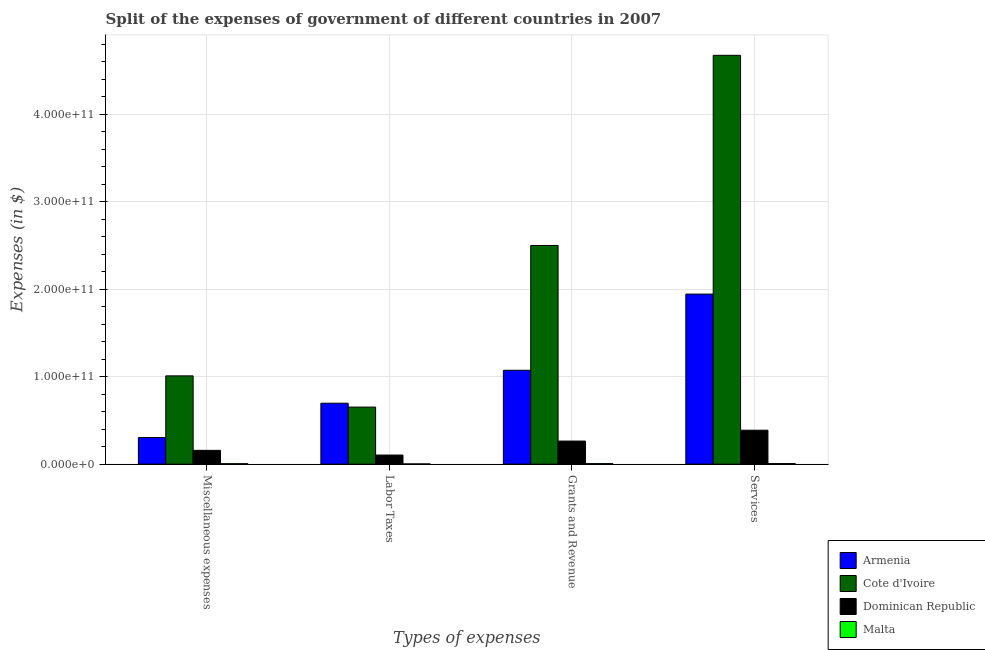How many different coloured bars are there?
Provide a succinct answer. 4. Are the number of bars per tick equal to the number of legend labels?
Offer a very short reply. Yes. How many bars are there on the 2nd tick from the left?
Offer a very short reply. 4. How many bars are there on the 2nd tick from the right?
Your response must be concise. 4. What is the label of the 1st group of bars from the left?
Provide a short and direct response. Miscellaneous expenses. What is the amount spent on services in Malta?
Keep it short and to the point. 6.25e+08. Across all countries, what is the maximum amount spent on grants and revenue?
Ensure brevity in your answer.  2.50e+11. Across all countries, what is the minimum amount spent on labor taxes?
Offer a terse response. 2.10e+08. In which country was the amount spent on miscellaneous expenses maximum?
Make the answer very short. Cote d'Ivoire. In which country was the amount spent on labor taxes minimum?
Your answer should be very brief. Malta. What is the total amount spent on services in the graph?
Make the answer very short. 7.01e+11. What is the difference between the amount spent on services in Malta and that in Dominican Republic?
Give a very brief answer. -3.81e+1. What is the difference between the amount spent on grants and revenue in Armenia and the amount spent on services in Malta?
Make the answer very short. 1.07e+11. What is the average amount spent on services per country?
Offer a very short reply. 1.75e+11. What is the difference between the amount spent on grants and revenue and amount spent on services in Armenia?
Your answer should be very brief. -8.71e+1. In how many countries, is the amount spent on labor taxes greater than 240000000000 $?
Make the answer very short. 0. What is the ratio of the amount spent on services in Armenia to that in Cote d'Ivoire?
Keep it short and to the point. 0.42. What is the difference between the highest and the second highest amount spent on services?
Offer a terse response. 2.73e+11. What is the difference between the highest and the lowest amount spent on miscellaneous expenses?
Keep it short and to the point. 1.00e+11. Is it the case that in every country, the sum of the amount spent on services and amount spent on labor taxes is greater than the sum of amount spent on grants and revenue and amount spent on miscellaneous expenses?
Provide a succinct answer. No. What does the 2nd bar from the left in Services represents?
Your answer should be compact. Cote d'Ivoire. What does the 2nd bar from the right in Miscellaneous expenses represents?
Make the answer very short. Dominican Republic. Is it the case that in every country, the sum of the amount spent on miscellaneous expenses and amount spent on labor taxes is greater than the amount spent on grants and revenue?
Provide a short and direct response. No. How many bars are there?
Provide a short and direct response. 16. Are all the bars in the graph horizontal?
Provide a succinct answer. No. How many countries are there in the graph?
Keep it short and to the point. 4. What is the difference between two consecutive major ticks on the Y-axis?
Ensure brevity in your answer.  1.00e+11. Are the values on the major ticks of Y-axis written in scientific E-notation?
Your response must be concise. Yes. Does the graph contain any zero values?
Provide a succinct answer. No. What is the title of the graph?
Keep it short and to the point. Split of the expenses of government of different countries in 2007. Does "Arab World" appear as one of the legend labels in the graph?
Offer a very short reply. No. What is the label or title of the X-axis?
Your answer should be very brief. Types of expenses. What is the label or title of the Y-axis?
Give a very brief answer. Expenses (in $). What is the Expenses (in $) of Armenia in Miscellaneous expenses?
Your response must be concise. 3.04e+1. What is the Expenses (in $) of Cote d'Ivoire in Miscellaneous expenses?
Offer a terse response. 1.01e+11. What is the Expenses (in $) of Dominican Republic in Miscellaneous expenses?
Your answer should be very brief. 1.57e+1. What is the Expenses (in $) of Malta in Miscellaneous expenses?
Your response must be concise. 4.99e+08. What is the Expenses (in $) in Armenia in Labor Taxes?
Offer a terse response. 6.96e+1. What is the Expenses (in $) of Cote d'Ivoire in Labor Taxes?
Your response must be concise. 6.52e+1. What is the Expenses (in $) of Dominican Republic in Labor Taxes?
Your answer should be compact. 1.04e+1. What is the Expenses (in $) of Malta in Labor Taxes?
Your answer should be compact. 2.10e+08. What is the Expenses (in $) in Armenia in Grants and Revenue?
Make the answer very short. 1.07e+11. What is the Expenses (in $) in Cote d'Ivoire in Grants and Revenue?
Ensure brevity in your answer.  2.50e+11. What is the Expenses (in $) in Dominican Republic in Grants and Revenue?
Provide a short and direct response. 2.64e+1. What is the Expenses (in $) in Malta in Grants and Revenue?
Your answer should be compact. 5.64e+08. What is the Expenses (in $) of Armenia in Services?
Make the answer very short. 1.94e+11. What is the Expenses (in $) of Cote d'Ivoire in Services?
Your answer should be compact. 4.67e+11. What is the Expenses (in $) of Dominican Republic in Services?
Offer a terse response. 3.88e+1. What is the Expenses (in $) of Malta in Services?
Give a very brief answer. 6.25e+08. Across all Types of expenses, what is the maximum Expenses (in $) of Armenia?
Make the answer very short. 1.94e+11. Across all Types of expenses, what is the maximum Expenses (in $) of Cote d'Ivoire?
Give a very brief answer. 4.67e+11. Across all Types of expenses, what is the maximum Expenses (in $) in Dominican Republic?
Your response must be concise. 3.88e+1. Across all Types of expenses, what is the maximum Expenses (in $) of Malta?
Offer a very short reply. 6.25e+08. Across all Types of expenses, what is the minimum Expenses (in $) of Armenia?
Your response must be concise. 3.04e+1. Across all Types of expenses, what is the minimum Expenses (in $) in Cote d'Ivoire?
Keep it short and to the point. 6.52e+1. Across all Types of expenses, what is the minimum Expenses (in $) of Dominican Republic?
Make the answer very short. 1.04e+1. Across all Types of expenses, what is the minimum Expenses (in $) of Malta?
Offer a very short reply. 2.10e+08. What is the total Expenses (in $) in Armenia in the graph?
Give a very brief answer. 4.02e+11. What is the total Expenses (in $) in Cote d'Ivoire in the graph?
Your response must be concise. 8.84e+11. What is the total Expenses (in $) of Dominican Republic in the graph?
Provide a short and direct response. 9.12e+1. What is the total Expenses (in $) of Malta in the graph?
Ensure brevity in your answer.  1.90e+09. What is the difference between the Expenses (in $) of Armenia in Miscellaneous expenses and that in Labor Taxes?
Provide a short and direct response. -3.92e+1. What is the difference between the Expenses (in $) in Cote d'Ivoire in Miscellaneous expenses and that in Labor Taxes?
Keep it short and to the point. 3.57e+1. What is the difference between the Expenses (in $) of Dominican Republic in Miscellaneous expenses and that in Labor Taxes?
Offer a very short reply. 5.37e+09. What is the difference between the Expenses (in $) of Malta in Miscellaneous expenses and that in Labor Taxes?
Your answer should be very brief. 2.90e+08. What is the difference between the Expenses (in $) in Armenia in Miscellaneous expenses and that in Grants and Revenue?
Offer a terse response. -7.69e+1. What is the difference between the Expenses (in $) in Cote d'Ivoire in Miscellaneous expenses and that in Grants and Revenue?
Keep it short and to the point. -1.49e+11. What is the difference between the Expenses (in $) of Dominican Republic in Miscellaneous expenses and that in Grants and Revenue?
Give a very brief answer. -1.06e+1. What is the difference between the Expenses (in $) of Malta in Miscellaneous expenses and that in Grants and Revenue?
Offer a very short reply. -6.48e+07. What is the difference between the Expenses (in $) in Armenia in Miscellaneous expenses and that in Services?
Offer a very short reply. -1.64e+11. What is the difference between the Expenses (in $) in Cote d'Ivoire in Miscellaneous expenses and that in Services?
Keep it short and to the point. -3.66e+11. What is the difference between the Expenses (in $) of Dominican Republic in Miscellaneous expenses and that in Services?
Your answer should be very brief. -2.30e+1. What is the difference between the Expenses (in $) in Malta in Miscellaneous expenses and that in Services?
Your response must be concise. -1.26e+08. What is the difference between the Expenses (in $) of Armenia in Labor Taxes and that in Grants and Revenue?
Keep it short and to the point. -3.76e+1. What is the difference between the Expenses (in $) in Cote d'Ivoire in Labor Taxes and that in Grants and Revenue?
Offer a terse response. -1.85e+11. What is the difference between the Expenses (in $) in Dominican Republic in Labor Taxes and that in Grants and Revenue?
Your answer should be very brief. -1.60e+1. What is the difference between the Expenses (in $) in Malta in Labor Taxes and that in Grants and Revenue?
Make the answer very short. -3.54e+08. What is the difference between the Expenses (in $) in Armenia in Labor Taxes and that in Services?
Keep it short and to the point. -1.25e+11. What is the difference between the Expenses (in $) of Cote d'Ivoire in Labor Taxes and that in Services?
Provide a short and direct response. -4.02e+11. What is the difference between the Expenses (in $) in Dominican Republic in Labor Taxes and that in Services?
Keep it short and to the point. -2.84e+1. What is the difference between the Expenses (in $) in Malta in Labor Taxes and that in Services?
Provide a succinct answer. -4.15e+08. What is the difference between the Expenses (in $) of Armenia in Grants and Revenue and that in Services?
Ensure brevity in your answer.  -8.71e+1. What is the difference between the Expenses (in $) in Cote d'Ivoire in Grants and Revenue and that in Services?
Your answer should be compact. -2.17e+11. What is the difference between the Expenses (in $) of Dominican Republic in Grants and Revenue and that in Services?
Your answer should be compact. -1.24e+1. What is the difference between the Expenses (in $) of Malta in Grants and Revenue and that in Services?
Give a very brief answer. -6.09e+07. What is the difference between the Expenses (in $) of Armenia in Miscellaneous expenses and the Expenses (in $) of Cote d'Ivoire in Labor Taxes?
Make the answer very short. -3.48e+1. What is the difference between the Expenses (in $) of Armenia in Miscellaneous expenses and the Expenses (in $) of Dominican Republic in Labor Taxes?
Make the answer very short. 2.00e+1. What is the difference between the Expenses (in $) in Armenia in Miscellaneous expenses and the Expenses (in $) in Malta in Labor Taxes?
Give a very brief answer. 3.02e+1. What is the difference between the Expenses (in $) in Cote d'Ivoire in Miscellaneous expenses and the Expenses (in $) in Dominican Republic in Labor Taxes?
Provide a short and direct response. 9.05e+1. What is the difference between the Expenses (in $) of Cote d'Ivoire in Miscellaneous expenses and the Expenses (in $) of Malta in Labor Taxes?
Provide a short and direct response. 1.01e+11. What is the difference between the Expenses (in $) in Dominican Republic in Miscellaneous expenses and the Expenses (in $) in Malta in Labor Taxes?
Provide a short and direct response. 1.55e+1. What is the difference between the Expenses (in $) in Armenia in Miscellaneous expenses and the Expenses (in $) in Cote d'Ivoire in Grants and Revenue?
Your response must be concise. -2.20e+11. What is the difference between the Expenses (in $) in Armenia in Miscellaneous expenses and the Expenses (in $) in Dominican Republic in Grants and Revenue?
Keep it short and to the point. 4.05e+09. What is the difference between the Expenses (in $) in Armenia in Miscellaneous expenses and the Expenses (in $) in Malta in Grants and Revenue?
Your answer should be compact. 2.98e+1. What is the difference between the Expenses (in $) in Cote d'Ivoire in Miscellaneous expenses and the Expenses (in $) in Dominican Republic in Grants and Revenue?
Give a very brief answer. 7.45e+1. What is the difference between the Expenses (in $) in Cote d'Ivoire in Miscellaneous expenses and the Expenses (in $) in Malta in Grants and Revenue?
Keep it short and to the point. 1.00e+11. What is the difference between the Expenses (in $) in Dominican Republic in Miscellaneous expenses and the Expenses (in $) in Malta in Grants and Revenue?
Your response must be concise. 1.52e+1. What is the difference between the Expenses (in $) of Armenia in Miscellaneous expenses and the Expenses (in $) of Cote d'Ivoire in Services?
Ensure brevity in your answer.  -4.37e+11. What is the difference between the Expenses (in $) of Armenia in Miscellaneous expenses and the Expenses (in $) of Dominican Republic in Services?
Offer a very short reply. -8.36e+09. What is the difference between the Expenses (in $) of Armenia in Miscellaneous expenses and the Expenses (in $) of Malta in Services?
Make the answer very short. 2.98e+1. What is the difference between the Expenses (in $) of Cote d'Ivoire in Miscellaneous expenses and the Expenses (in $) of Dominican Republic in Services?
Keep it short and to the point. 6.21e+1. What is the difference between the Expenses (in $) in Cote d'Ivoire in Miscellaneous expenses and the Expenses (in $) in Malta in Services?
Give a very brief answer. 1.00e+11. What is the difference between the Expenses (in $) of Dominican Republic in Miscellaneous expenses and the Expenses (in $) of Malta in Services?
Offer a very short reply. 1.51e+1. What is the difference between the Expenses (in $) in Armenia in Labor Taxes and the Expenses (in $) in Cote d'Ivoire in Grants and Revenue?
Offer a very short reply. -1.80e+11. What is the difference between the Expenses (in $) in Armenia in Labor Taxes and the Expenses (in $) in Dominican Republic in Grants and Revenue?
Your response must be concise. 4.33e+1. What is the difference between the Expenses (in $) of Armenia in Labor Taxes and the Expenses (in $) of Malta in Grants and Revenue?
Keep it short and to the point. 6.91e+1. What is the difference between the Expenses (in $) in Cote d'Ivoire in Labor Taxes and the Expenses (in $) in Dominican Republic in Grants and Revenue?
Offer a very short reply. 3.88e+1. What is the difference between the Expenses (in $) of Cote d'Ivoire in Labor Taxes and the Expenses (in $) of Malta in Grants and Revenue?
Your answer should be compact. 6.46e+1. What is the difference between the Expenses (in $) in Dominican Republic in Labor Taxes and the Expenses (in $) in Malta in Grants and Revenue?
Your answer should be very brief. 9.80e+09. What is the difference between the Expenses (in $) of Armenia in Labor Taxes and the Expenses (in $) of Cote d'Ivoire in Services?
Give a very brief answer. -3.98e+11. What is the difference between the Expenses (in $) of Armenia in Labor Taxes and the Expenses (in $) of Dominican Republic in Services?
Provide a short and direct response. 3.09e+1. What is the difference between the Expenses (in $) in Armenia in Labor Taxes and the Expenses (in $) in Malta in Services?
Keep it short and to the point. 6.90e+1. What is the difference between the Expenses (in $) of Cote d'Ivoire in Labor Taxes and the Expenses (in $) of Dominican Republic in Services?
Offer a very short reply. 2.64e+1. What is the difference between the Expenses (in $) of Cote d'Ivoire in Labor Taxes and the Expenses (in $) of Malta in Services?
Your answer should be compact. 6.46e+1. What is the difference between the Expenses (in $) in Dominican Republic in Labor Taxes and the Expenses (in $) in Malta in Services?
Provide a short and direct response. 9.74e+09. What is the difference between the Expenses (in $) in Armenia in Grants and Revenue and the Expenses (in $) in Cote d'Ivoire in Services?
Give a very brief answer. -3.60e+11. What is the difference between the Expenses (in $) of Armenia in Grants and Revenue and the Expenses (in $) of Dominican Republic in Services?
Your answer should be compact. 6.85e+1. What is the difference between the Expenses (in $) of Armenia in Grants and Revenue and the Expenses (in $) of Malta in Services?
Provide a succinct answer. 1.07e+11. What is the difference between the Expenses (in $) in Cote d'Ivoire in Grants and Revenue and the Expenses (in $) in Dominican Republic in Services?
Provide a succinct answer. 2.11e+11. What is the difference between the Expenses (in $) of Cote d'Ivoire in Grants and Revenue and the Expenses (in $) of Malta in Services?
Offer a terse response. 2.49e+11. What is the difference between the Expenses (in $) in Dominican Republic in Grants and Revenue and the Expenses (in $) in Malta in Services?
Your answer should be compact. 2.57e+1. What is the average Expenses (in $) of Armenia per Types of expenses?
Offer a terse response. 1.00e+11. What is the average Expenses (in $) in Cote d'Ivoire per Types of expenses?
Provide a short and direct response. 2.21e+11. What is the average Expenses (in $) of Dominican Republic per Types of expenses?
Offer a very short reply. 2.28e+1. What is the average Expenses (in $) of Malta per Types of expenses?
Your answer should be compact. 4.75e+08. What is the difference between the Expenses (in $) in Armenia and Expenses (in $) in Cote d'Ivoire in Miscellaneous expenses?
Offer a very short reply. -7.05e+1. What is the difference between the Expenses (in $) of Armenia and Expenses (in $) of Dominican Republic in Miscellaneous expenses?
Your answer should be compact. 1.47e+1. What is the difference between the Expenses (in $) of Armenia and Expenses (in $) of Malta in Miscellaneous expenses?
Your answer should be compact. 2.99e+1. What is the difference between the Expenses (in $) of Cote d'Ivoire and Expenses (in $) of Dominican Republic in Miscellaneous expenses?
Offer a terse response. 8.52e+1. What is the difference between the Expenses (in $) in Cote d'Ivoire and Expenses (in $) in Malta in Miscellaneous expenses?
Offer a very short reply. 1.00e+11. What is the difference between the Expenses (in $) in Dominican Republic and Expenses (in $) in Malta in Miscellaneous expenses?
Make the answer very short. 1.52e+1. What is the difference between the Expenses (in $) of Armenia and Expenses (in $) of Cote d'Ivoire in Labor Taxes?
Your answer should be very brief. 4.44e+09. What is the difference between the Expenses (in $) of Armenia and Expenses (in $) of Dominican Republic in Labor Taxes?
Your answer should be compact. 5.93e+1. What is the difference between the Expenses (in $) in Armenia and Expenses (in $) in Malta in Labor Taxes?
Provide a succinct answer. 6.94e+1. What is the difference between the Expenses (in $) in Cote d'Ivoire and Expenses (in $) in Dominican Republic in Labor Taxes?
Give a very brief answer. 5.48e+1. What is the difference between the Expenses (in $) in Cote d'Ivoire and Expenses (in $) in Malta in Labor Taxes?
Offer a terse response. 6.50e+1. What is the difference between the Expenses (in $) of Dominican Republic and Expenses (in $) of Malta in Labor Taxes?
Offer a very short reply. 1.02e+1. What is the difference between the Expenses (in $) in Armenia and Expenses (in $) in Cote d'Ivoire in Grants and Revenue?
Your answer should be compact. -1.43e+11. What is the difference between the Expenses (in $) of Armenia and Expenses (in $) of Dominican Republic in Grants and Revenue?
Provide a succinct answer. 8.09e+1. What is the difference between the Expenses (in $) of Armenia and Expenses (in $) of Malta in Grants and Revenue?
Offer a terse response. 1.07e+11. What is the difference between the Expenses (in $) of Cote d'Ivoire and Expenses (in $) of Dominican Republic in Grants and Revenue?
Your response must be concise. 2.24e+11. What is the difference between the Expenses (in $) in Cote d'Ivoire and Expenses (in $) in Malta in Grants and Revenue?
Your answer should be compact. 2.49e+11. What is the difference between the Expenses (in $) of Dominican Republic and Expenses (in $) of Malta in Grants and Revenue?
Provide a short and direct response. 2.58e+1. What is the difference between the Expenses (in $) of Armenia and Expenses (in $) of Cote d'Ivoire in Services?
Offer a very short reply. -2.73e+11. What is the difference between the Expenses (in $) of Armenia and Expenses (in $) of Dominican Republic in Services?
Your answer should be very brief. 1.56e+11. What is the difference between the Expenses (in $) in Armenia and Expenses (in $) in Malta in Services?
Make the answer very short. 1.94e+11. What is the difference between the Expenses (in $) of Cote d'Ivoire and Expenses (in $) of Dominican Republic in Services?
Your answer should be compact. 4.29e+11. What is the difference between the Expenses (in $) of Cote d'Ivoire and Expenses (in $) of Malta in Services?
Your response must be concise. 4.67e+11. What is the difference between the Expenses (in $) in Dominican Republic and Expenses (in $) in Malta in Services?
Offer a terse response. 3.81e+1. What is the ratio of the Expenses (in $) of Armenia in Miscellaneous expenses to that in Labor Taxes?
Offer a terse response. 0.44. What is the ratio of the Expenses (in $) of Cote d'Ivoire in Miscellaneous expenses to that in Labor Taxes?
Give a very brief answer. 1.55. What is the ratio of the Expenses (in $) of Dominican Republic in Miscellaneous expenses to that in Labor Taxes?
Provide a short and direct response. 1.52. What is the ratio of the Expenses (in $) of Malta in Miscellaneous expenses to that in Labor Taxes?
Provide a succinct answer. 2.38. What is the ratio of the Expenses (in $) in Armenia in Miscellaneous expenses to that in Grants and Revenue?
Your answer should be compact. 0.28. What is the ratio of the Expenses (in $) in Cote d'Ivoire in Miscellaneous expenses to that in Grants and Revenue?
Your answer should be compact. 0.4. What is the ratio of the Expenses (in $) in Dominican Republic in Miscellaneous expenses to that in Grants and Revenue?
Your answer should be compact. 0.6. What is the ratio of the Expenses (in $) of Malta in Miscellaneous expenses to that in Grants and Revenue?
Your response must be concise. 0.89. What is the ratio of the Expenses (in $) in Armenia in Miscellaneous expenses to that in Services?
Offer a very short reply. 0.16. What is the ratio of the Expenses (in $) in Cote d'Ivoire in Miscellaneous expenses to that in Services?
Keep it short and to the point. 0.22. What is the ratio of the Expenses (in $) in Dominican Republic in Miscellaneous expenses to that in Services?
Keep it short and to the point. 0.41. What is the ratio of the Expenses (in $) in Malta in Miscellaneous expenses to that in Services?
Make the answer very short. 0.8. What is the ratio of the Expenses (in $) of Armenia in Labor Taxes to that in Grants and Revenue?
Your response must be concise. 0.65. What is the ratio of the Expenses (in $) of Cote d'Ivoire in Labor Taxes to that in Grants and Revenue?
Ensure brevity in your answer.  0.26. What is the ratio of the Expenses (in $) of Dominican Republic in Labor Taxes to that in Grants and Revenue?
Make the answer very short. 0.39. What is the ratio of the Expenses (in $) of Malta in Labor Taxes to that in Grants and Revenue?
Ensure brevity in your answer.  0.37. What is the ratio of the Expenses (in $) of Armenia in Labor Taxes to that in Services?
Ensure brevity in your answer.  0.36. What is the ratio of the Expenses (in $) of Cote d'Ivoire in Labor Taxes to that in Services?
Provide a succinct answer. 0.14. What is the ratio of the Expenses (in $) of Dominican Republic in Labor Taxes to that in Services?
Provide a short and direct response. 0.27. What is the ratio of the Expenses (in $) of Malta in Labor Taxes to that in Services?
Keep it short and to the point. 0.34. What is the ratio of the Expenses (in $) of Armenia in Grants and Revenue to that in Services?
Your response must be concise. 0.55. What is the ratio of the Expenses (in $) of Cote d'Ivoire in Grants and Revenue to that in Services?
Offer a terse response. 0.53. What is the ratio of the Expenses (in $) in Dominican Republic in Grants and Revenue to that in Services?
Offer a terse response. 0.68. What is the ratio of the Expenses (in $) in Malta in Grants and Revenue to that in Services?
Provide a short and direct response. 0.9. What is the difference between the highest and the second highest Expenses (in $) in Armenia?
Your response must be concise. 8.71e+1. What is the difference between the highest and the second highest Expenses (in $) of Cote d'Ivoire?
Your response must be concise. 2.17e+11. What is the difference between the highest and the second highest Expenses (in $) of Dominican Republic?
Your answer should be very brief. 1.24e+1. What is the difference between the highest and the second highest Expenses (in $) in Malta?
Offer a terse response. 6.09e+07. What is the difference between the highest and the lowest Expenses (in $) in Armenia?
Offer a terse response. 1.64e+11. What is the difference between the highest and the lowest Expenses (in $) of Cote d'Ivoire?
Ensure brevity in your answer.  4.02e+11. What is the difference between the highest and the lowest Expenses (in $) of Dominican Republic?
Ensure brevity in your answer.  2.84e+1. What is the difference between the highest and the lowest Expenses (in $) in Malta?
Provide a succinct answer. 4.15e+08. 